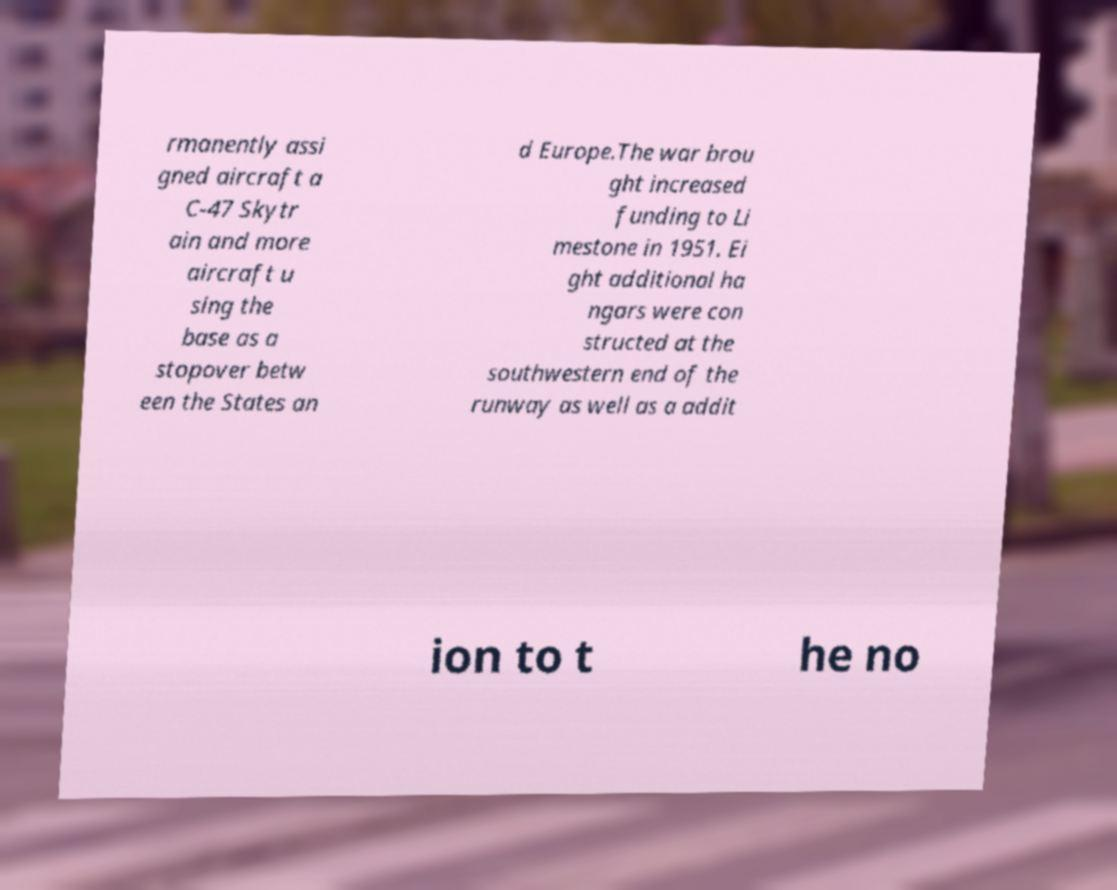Could you extract and type out the text from this image? rmanently assi gned aircraft a C-47 Skytr ain and more aircraft u sing the base as a stopover betw een the States an d Europe.The war brou ght increased funding to Li mestone in 1951. Ei ght additional ha ngars were con structed at the southwestern end of the runway as well as a addit ion to t he no 